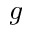<formula> <loc_0><loc_0><loc_500><loc_500>^ { g }</formula> 